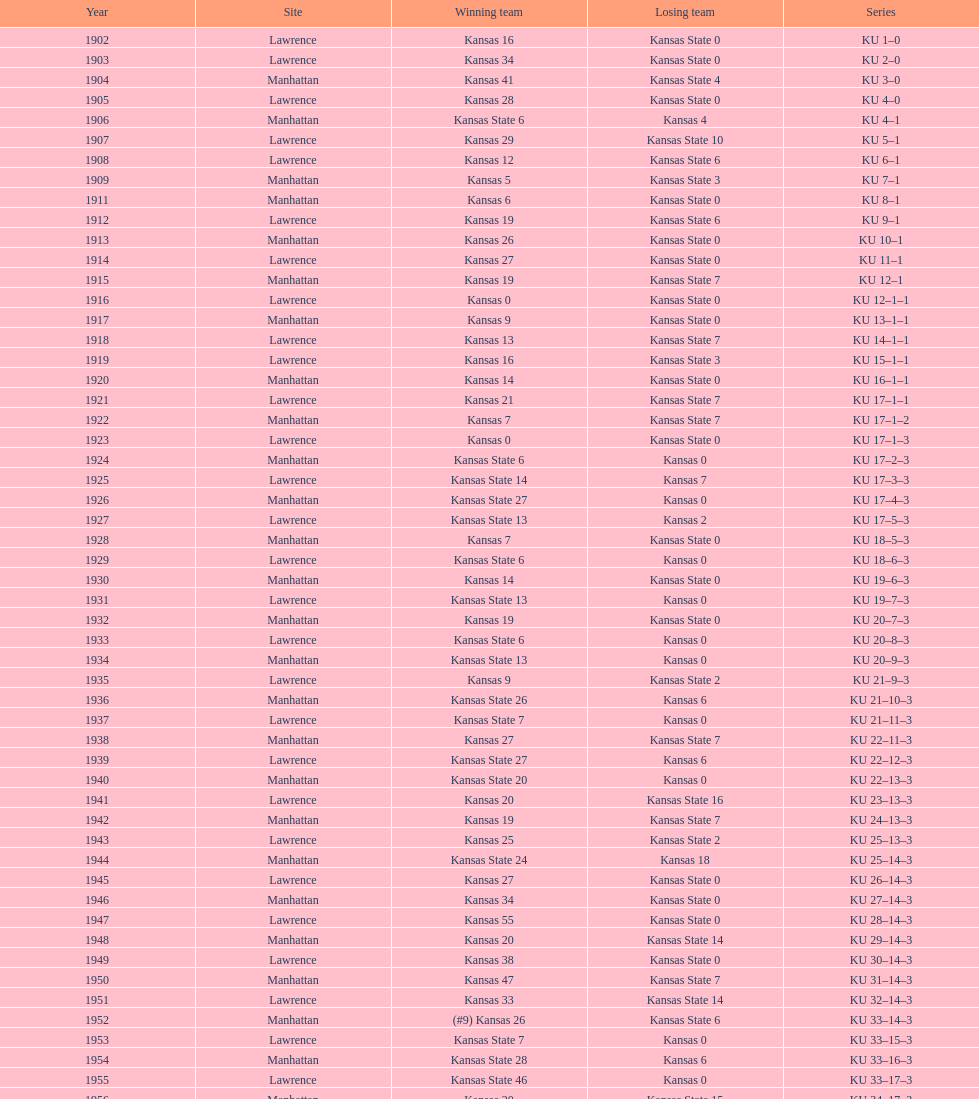Pre-1950, what was kansas' highest point total? 55. 